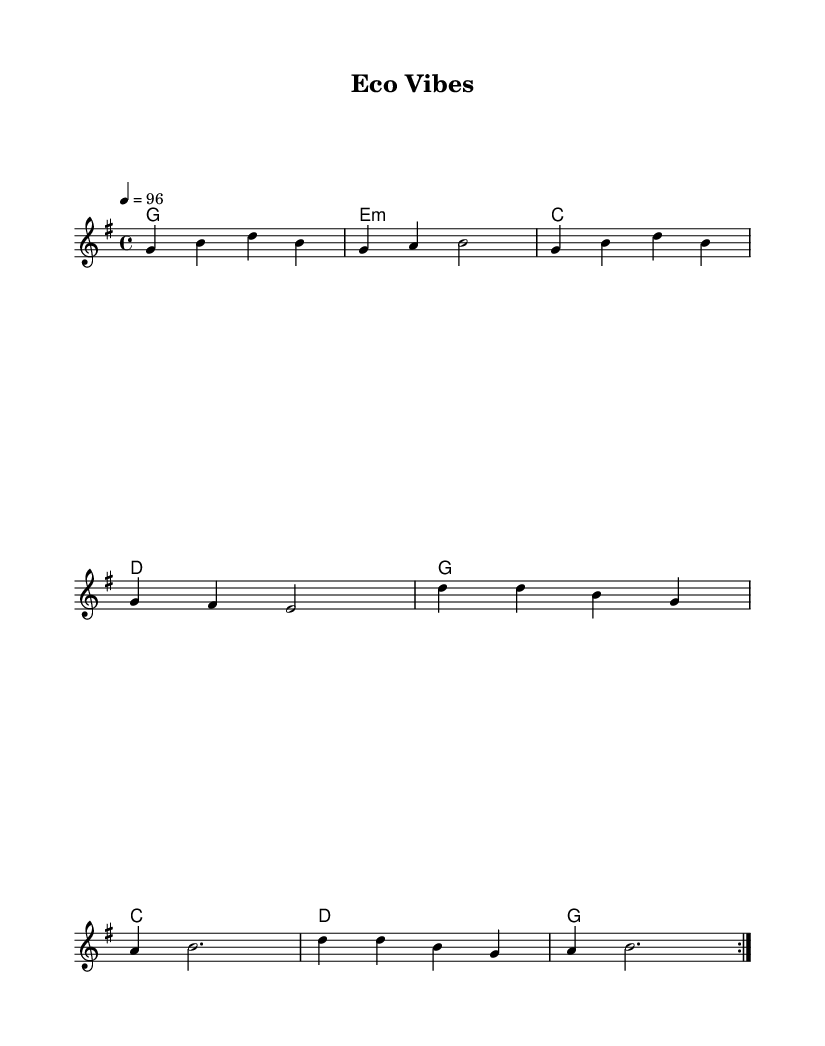What is the key signature of this music? The key signature is G major, which includes one sharp, F#. This can be identified from the global settings at the beginning of the sheet music.
Answer: G major What is the time signature of this music? The time signature is 4/4, which indicates four beats per measure. This is also outlined in the global settings.
Answer: 4/4 What is the tempo marking? The tempo marking is 96 beats per minute, indicated by "4 = 96" in the global settings. This shows how fast the music should be played.
Answer: 96 How many measures are in the verse section? There are four measures in the verse section. This can be deduced by counting the measures in the melodyVerse section.
Answer: 4 What is the main theme of the lyrics in the chorus? The main theme in the chorus is sustainability and eco-friendliness, highlighted by phrases that emphasize living green and feeling clean. The lyrics explicitly mention sustainability’s uplifting qualities.
Answer: Sustainability What chords are used in the chorus? The chords used in the chorus are D, G, A, and B. Analyzing the chordmode section, we can see that these are the prominent chords accompanying the melody in that section.
Answer: D, G, A, B 